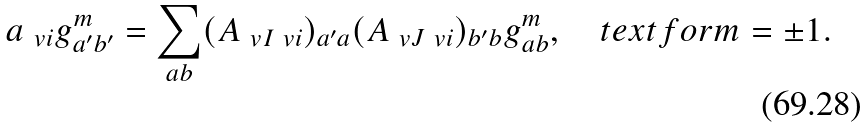Convert formula to latex. <formula><loc_0><loc_0><loc_500><loc_500>\L a _ { \ v i } g ^ { m } _ { a ^ { \prime } b ^ { \prime } } = \sum _ { a b } ( A _ { \ v I \ v i } ) _ { a ^ { \prime } a } ( A _ { \ v J \ v i } ) _ { b ^ { \prime } b } g ^ { m } _ { a b } , \quad t e x t { f o r } m = \pm 1 .</formula> 